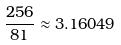Convert formula to latex. <formula><loc_0><loc_0><loc_500><loc_500>\frac { 2 5 6 } { 8 1 } \approx 3 . 1 6 0 4 9</formula> 